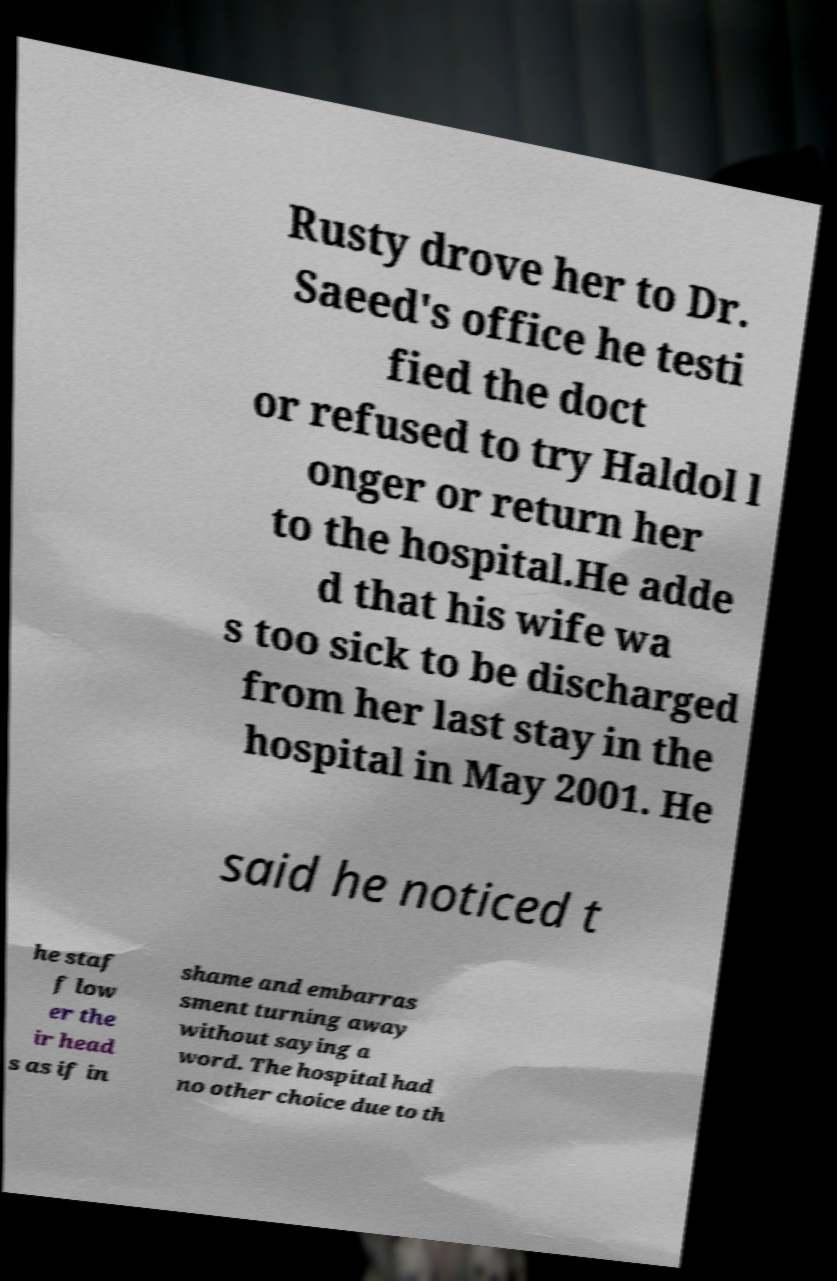Please identify and transcribe the text found in this image. Rusty drove her to Dr. Saeed's office he testi fied the doct or refused to try Haldol l onger or return her to the hospital.He adde d that his wife wa s too sick to be discharged from her last stay in the hospital in May 2001. He said he noticed t he staf f low er the ir head s as if in shame and embarras sment turning away without saying a word. The hospital had no other choice due to th 